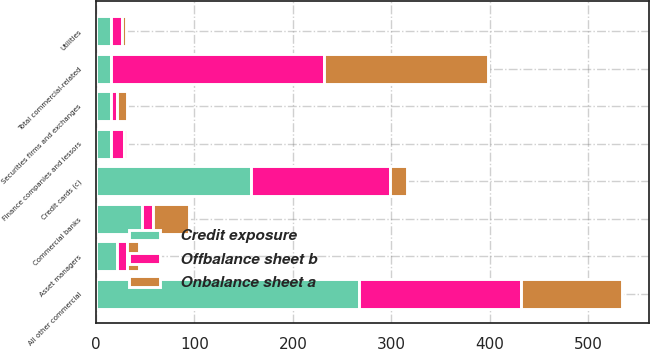Convert chart to OTSL. <chart><loc_0><loc_0><loc_500><loc_500><stacked_bar_chart><ecel><fcel>Commercial banks<fcel>Asset managers<fcel>Securities firms and exchanges<fcel>Finance companies and lessors<fcel>Utilities<fcel>All other commercial<fcel>Total commercial-related<fcel>Credit cards (c)<nl><fcel>Credit exposure<fcel>47.1<fcel>21.8<fcel>15.6<fcel>15.6<fcel>15.3<fcel>267.3<fcel>15.6<fcel>157.9<nl><fcel>Onbalance sheet a<fcel>36.5<fcel>11.7<fcel>9.3<fcel>3.1<fcel>3.7<fcel>102.7<fcel>167<fcel>16.8<nl><fcel>Offbalance sheet b<fcel>10.6<fcel>10.1<fcel>6.3<fcel>12.5<fcel>11.6<fcel>164.6<fcel>215.7<fcel>141.1<nl></chart> 